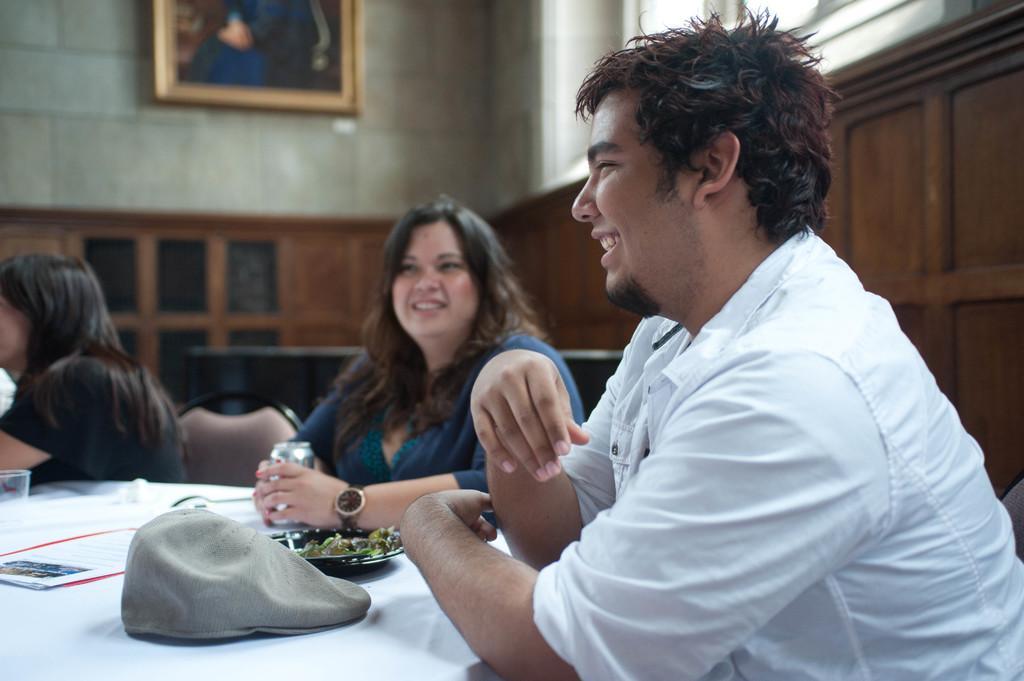Describe this image in one or two sentences. On the right side of the image there is a man sitting and smiling. In front of him there is a table with a cap, plate with food item and also there are few cards. Beside the man there is a lady sitting and on her hand there is a watch and also she is holding a can in her hand. Beside her there is a lady sitting. In the background there is a wooden wall. Above that there is a wall with a window and a frame. 